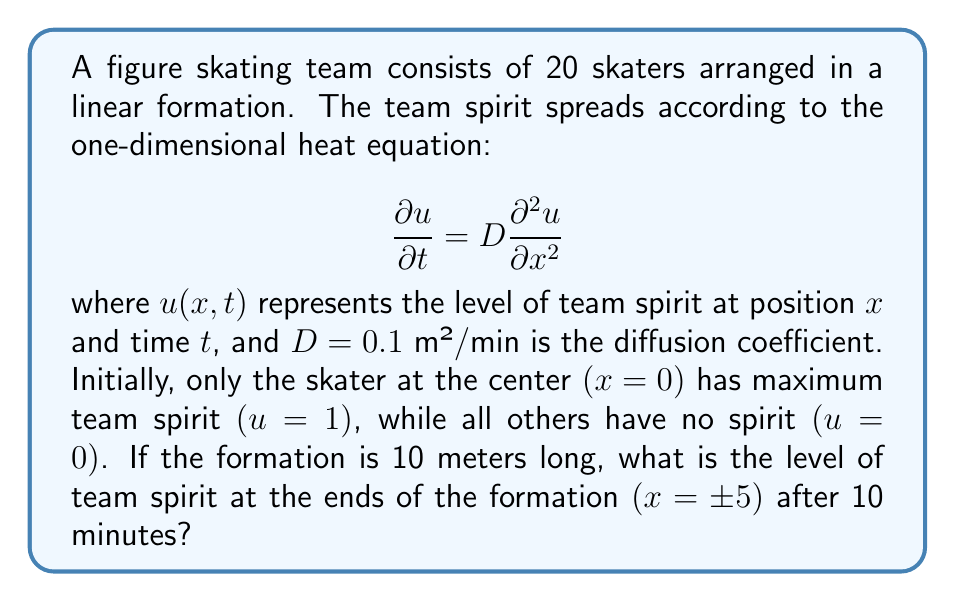What is the answer to this math problem? To solve this problem, we'll use the solution to the one-dimensional heat equation for an infinite domain with an initial point source:

$$u(x,t) = \frac{1}{\sqrt{4\pi Dt}} e^{-\frac{x^2}{4Dt}}$$

Step 1: Identify the known values:
- $D = 0.1$ m²/min
- $t = 10$ min
- $x = \pm 5$ m (we'll use $x = 5$ due to symmetry)

Step 2: Substitute these values into the equation:

$$u(5,10) = \frac{1}{\sqrt{4\pi(0.1)(10)}} e^{-\frac{5^2}{4(0.1)(10)}}$$

Step 3: Simplify the expression:

$$u(5,10) = \frac{1}{\sqrt{4\pi}} e^{-\frac{25}{4}}$$

Step 4: Calculate the result:

$$u(5,10) \approx 0.0484$$

This means that after 10 minutes, the level of team spirit at the ends of the formation is approximately 0.0484 or 4.84% of the maximum spirit.
Answer: 0.0484 